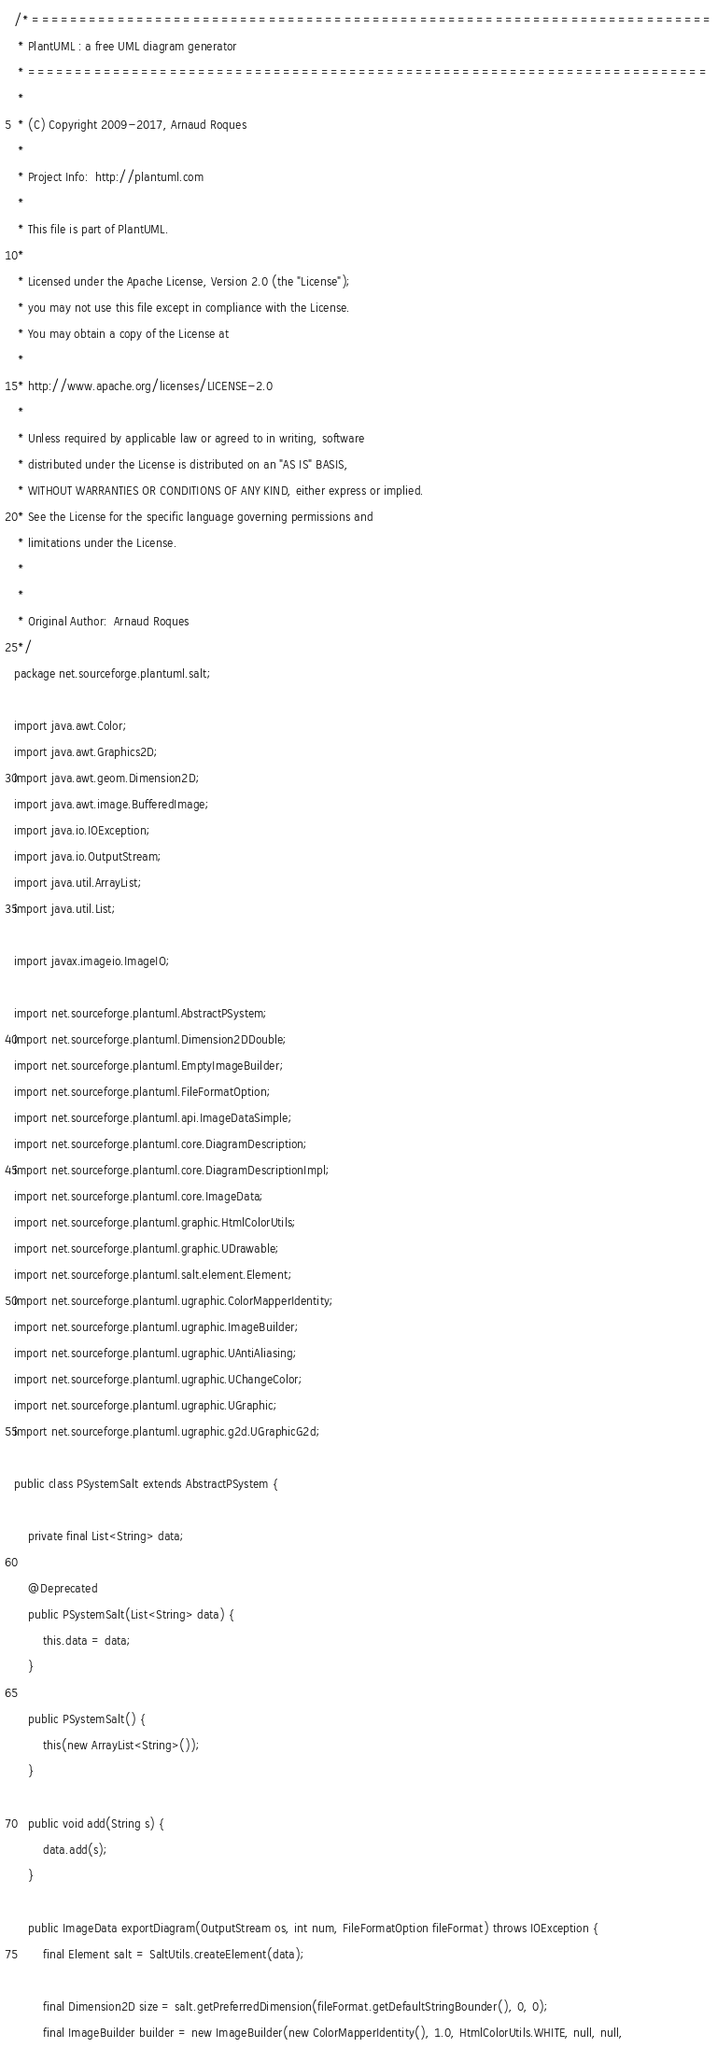Convert code to text. <code><loc_0><loc_0><loc_500><loc_500><_Java_>/* ========================================================================
 * PlantUML : a free UML diagram generator
 * ========================================================================
 *
 * (C) Copyright 2009-2017, Arnaud Roques
 *
 * Project Info:  http://plantuml.com
 * 
 * This file is part of PlantUML.
 *
 * Licensed under the Apache License, Version 2.0 (the "License");
 * you may not use this file except in compliance with the License.
 * You may obtain a copy of the License at
 * 
 * http://www.apache.org/licenses/LICENSE-2.0
 * 
 * Unless required by applicable law or agreed to in writing, software
 * distributed under the License is distributed on an "AS IS" BASIS,
 * WITHOUT WARRANTIES OR CONDITIONS OF ANY KIND, either express or implied.
 * See the License for the specific language governing permissions and
 * limitations under the License.
 *
 *
 * Original Author:  Arnaud Roques
 */
package net.sourceforge.plantuml.salt;

import java.awt.Color;
import java.awt.Graphics2D;
import java.awt.geom.Dimension2D;
import java.awt.image.BufferedImage;
import java.io.IOException;
import java.io.OutputStream;
import java.util.ArrayList;
import java.util.List;

import javax.imageio.ImageIO;

import net.sourceforge.plantuml.AbstractPSystem;
import net.sourceforge.plantuml.Dimension2DDouble;
import net.sourceforge.plantuml.EmptyImageBuilder;
import net.sourceforge.plantuml.FileFormatOption;
import net.sourceforge.plantuml.api.ImageDataSimple;
import net.sourceforge.plantuml.core.DiagramDescription;
import net.sourceforge.plantuml.core.DiagramDescriptionImpl;
import net.sourceforge.plantuml.core.ImageData;
import net.sourceforge.plantuml.graphic.HtmlColorUtils;
import net.sourceforge.plantuml.graphic.UDrawable;
import net.sourceforge.plantuml.salt.element.Element;
import net.sourceforge.plantuml.ugraphic.ColorMapperIdentity;
import net.sourceforge.plantuml.ugraphic.ImageBuilder;
import net.sourceforge.plantuml.ugraphic.UAntiAliasing;
import net.sourceforge.plantuml.ugraphic.UChangeColor;
import net.sourceforge.plantuml.ugraphic.UGraphic;
import net.sourceforge.plantuml.ugraphic.g2d.UGraphicG2d;

public class PSystemSalt extends AbstractPSystem {

	private final List<String> data;

	@Deprecated
	public PSystemSalt(List<String> data) {
		this.data = data;
	}

	public PSystemSalt() {
		this(new ArrayList<String>());
	}

	public void add(String s) {
		data.add(s);
	}

	public ImageData exportDiagram(OutputStream os, int num, FileFormatOption fileFormat) throws IOException {
		final Element salt = SaltUtils.createElement(data);

		final Dimension2D size = salt.getPreferredDimension(fileFormat.getDefaultStringBounder(), 0, 0);
		final ImageBuilder builder = new ImageBuilder(new ColorMapperIdentity(), 1.0, HtmlColorUtils.WHITE, null, null,</code> 